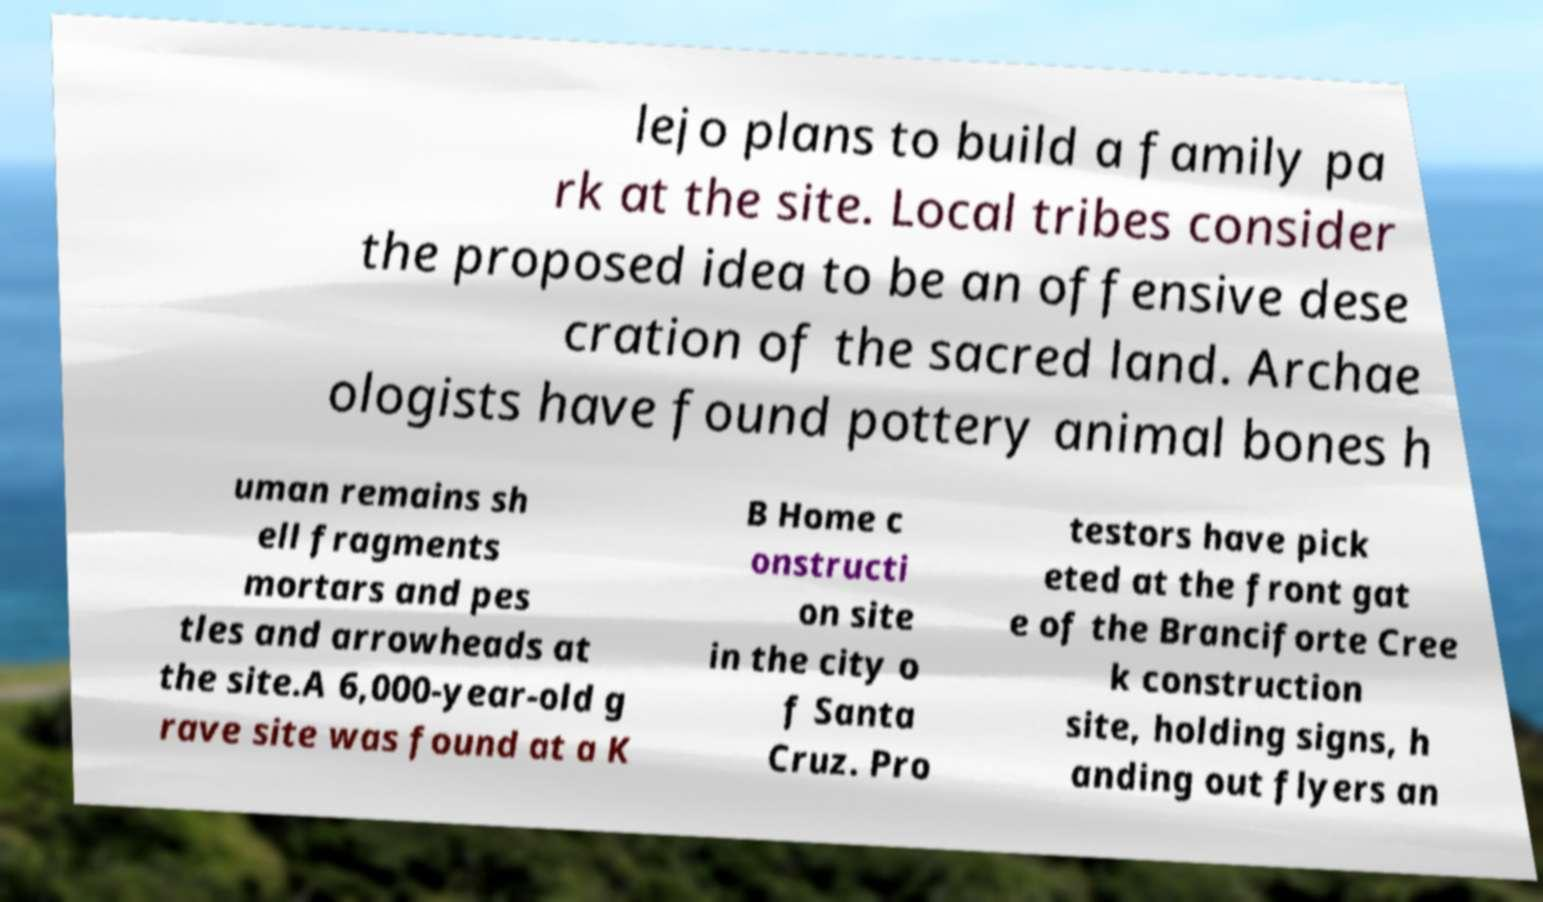What messages or text are displayed in this image? I need them in a readable, typed format. lejo plans to build a family pa rk at the site. Local tribes consider the proposed idea to be an offensive dese cration of the sacred land. Archae ologists have found pottery animal bones h uman remains sh ell fragments mortars and pes tles and arrowheads at the site.A 6,000-year-old g rave site was found at a K B Home c onstructi on site in the city o f Santa Cruz. Pro testors have pick eted at the front gat e of the Branciforte Cree k construction site, holding signs, h anding out flyers an 